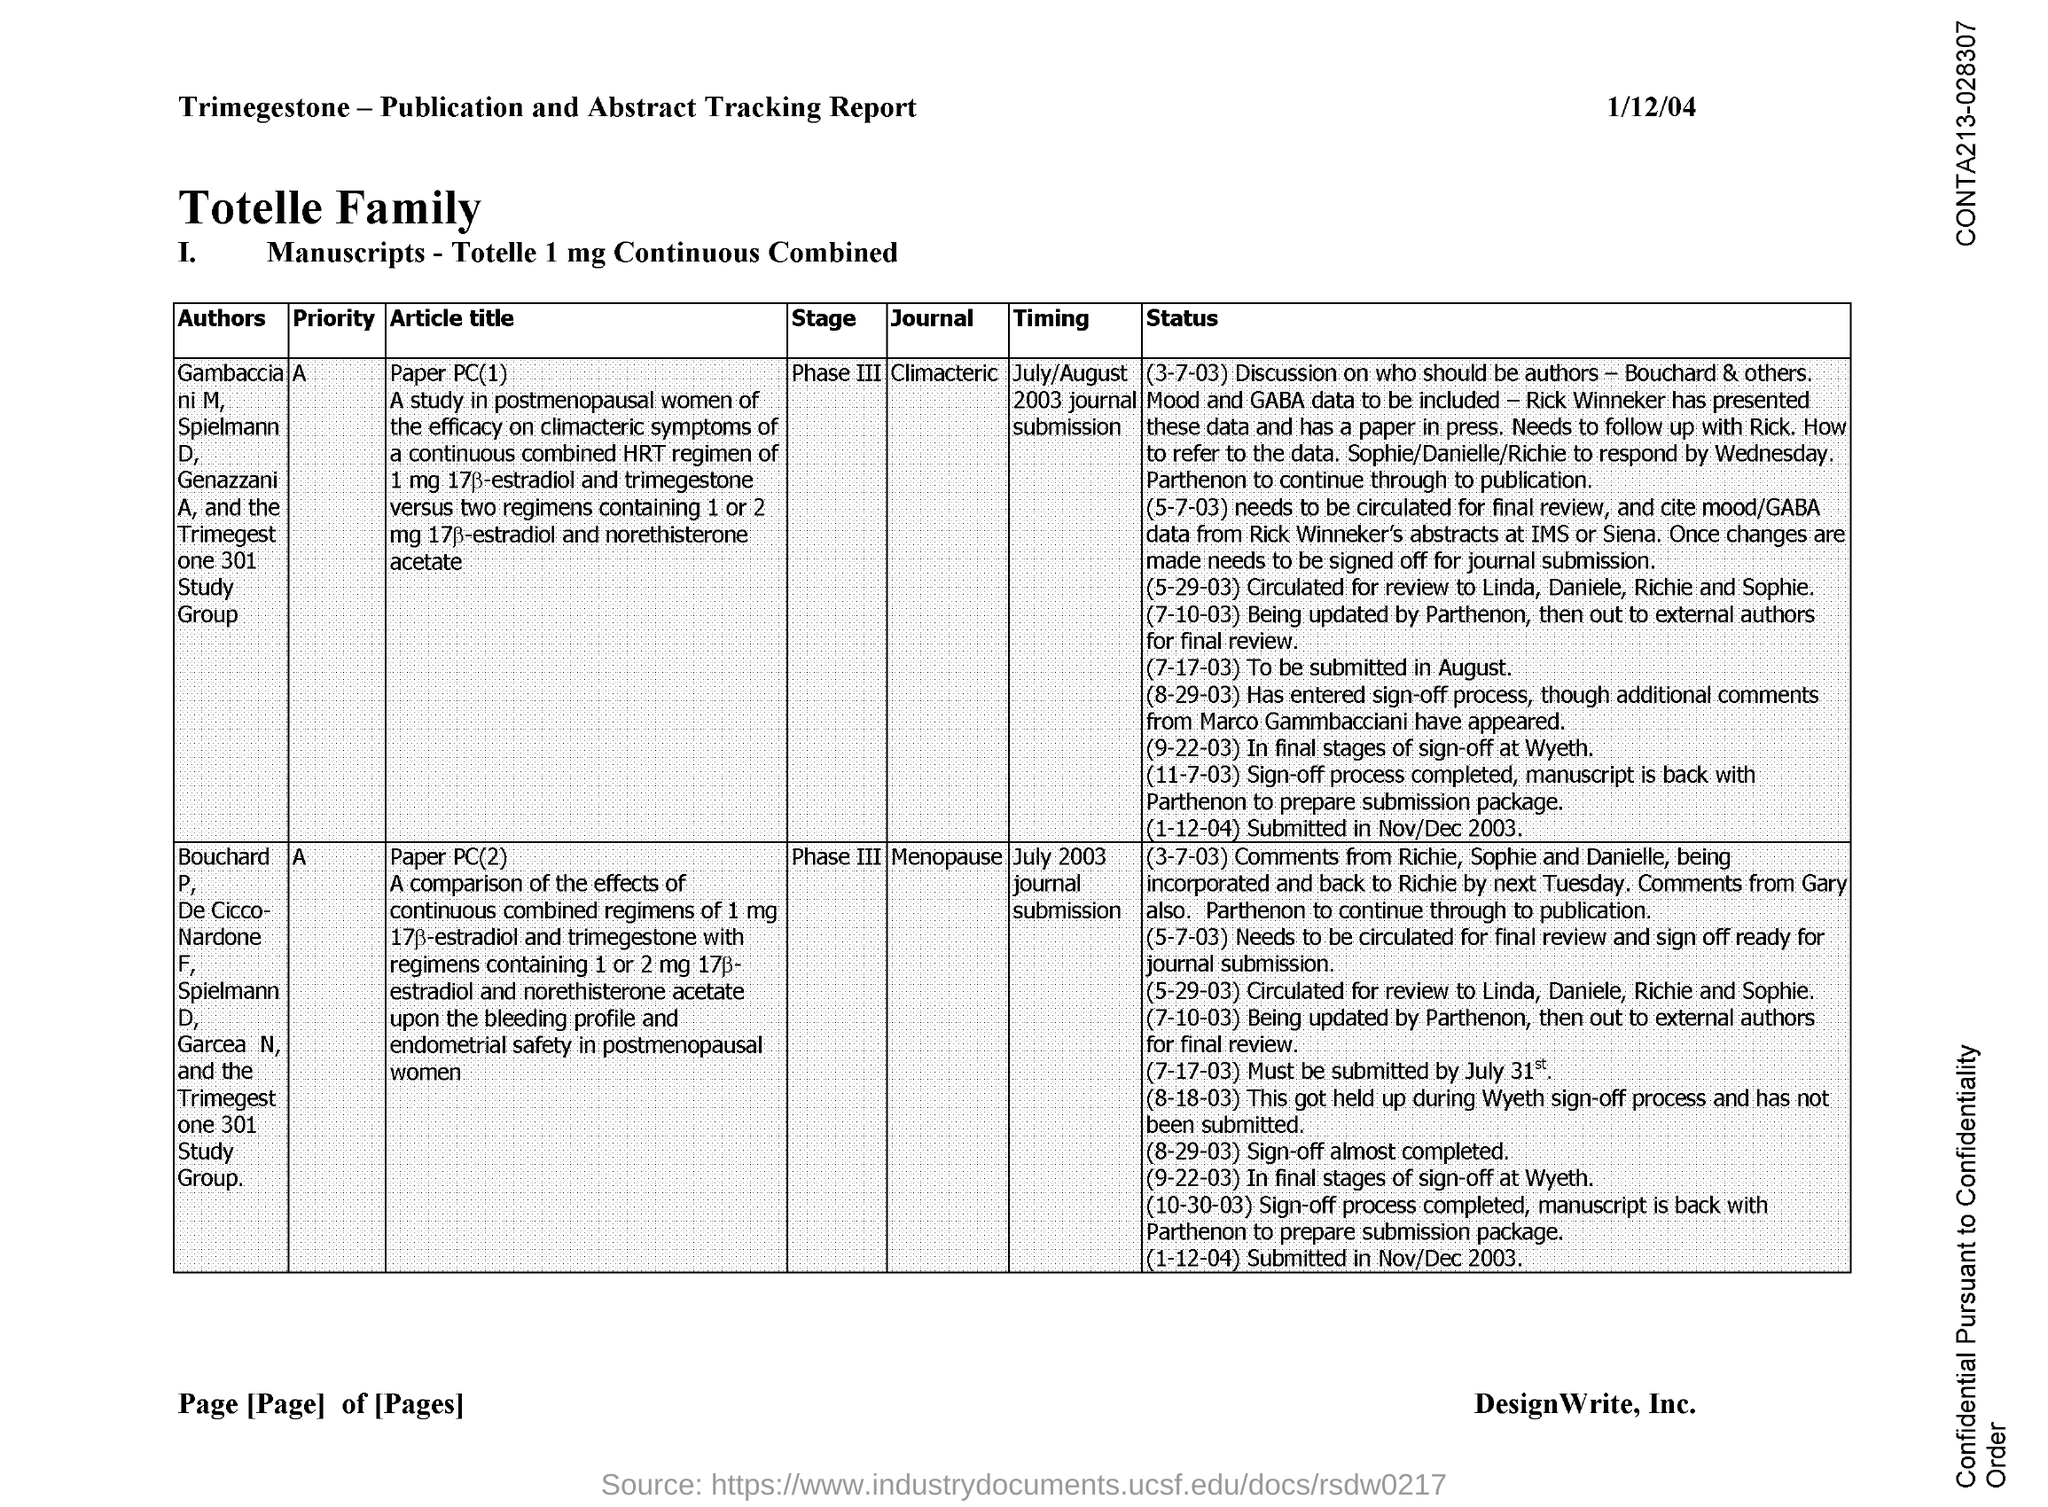What is the date on the document?
Your response must be concise. 1/12/04. 